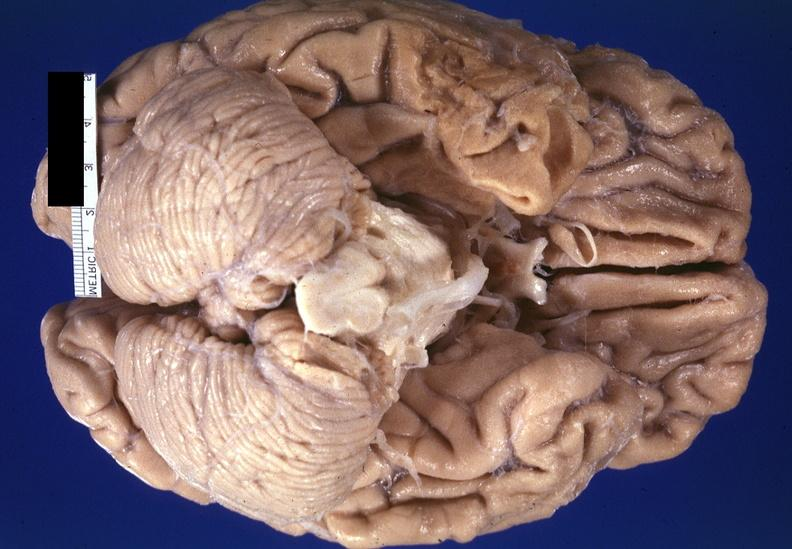s nervous present?
Answer the question using a single word or phrase. Yes 